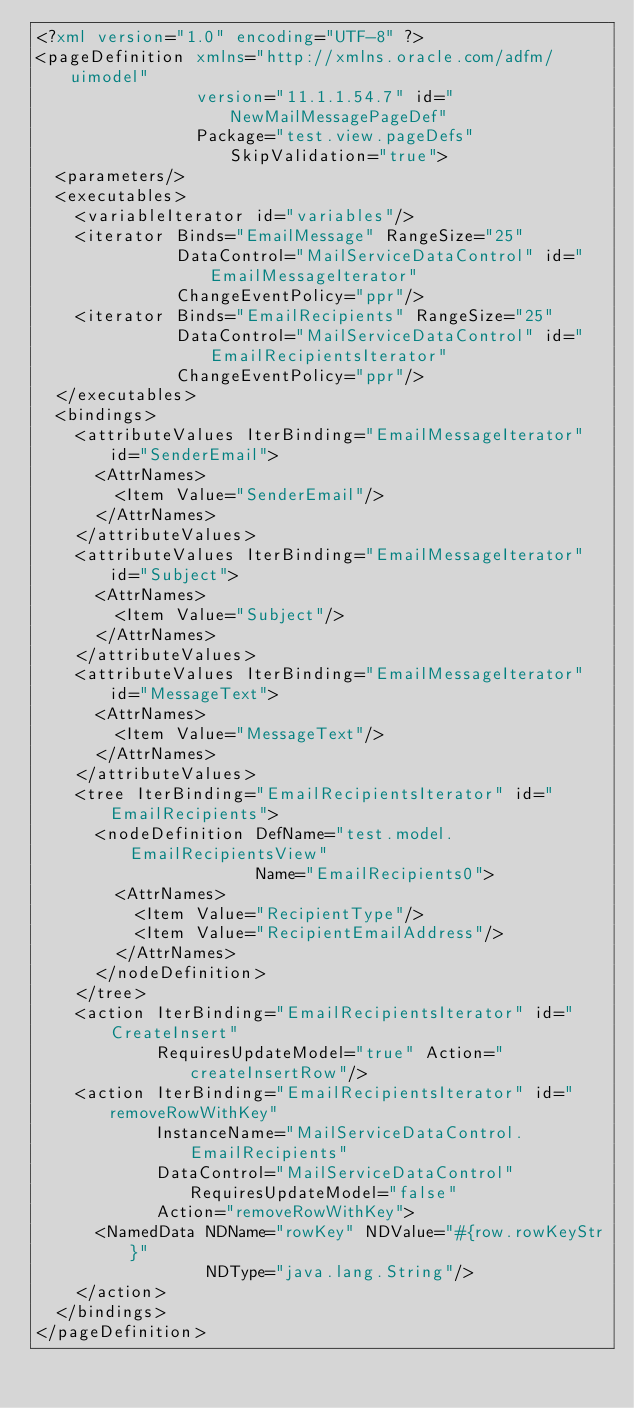<code> <loc_0><loc_0><loc_500><loc_500><_XML_><?xml version="1.0" encoding="UTF-8" ?>
<pageDefinition xmlns="http://xmlns.oracle.com/adfm/uimodel"
                version="11.1.1.54.7" id="NewMailMessagePageDef"
                Package="test.view.pageDefs" SkipValidation="true">
  <parameters/>
  <executables>
    <variableIterator id="variables"/>
    <iterator Binds="EmailMessage" RangeSize="25"
              DataControl="MailServiceDataControl" id="EmailMessageIterator"
              ChangeEventPolicy="ppr"/>
    <iterator Binds="EmailRecipients" RangeSize="25"
              DataControl="MailServiceDataControl" id="EmailRecipientsIterator"
              ChangeEventPolicy="ppr"/>
  </executables>
  <bindings>
    <attributeValues IterBinding="EmailMessageIterator" id="SenderEmail">
      <AttrNames>
        <Item Value="SenderEmail"/>
      </AttrNames>
    </attributeValues>
    <attributeValues IterBinding="EmailMessageIterator" id="Subject">
      <AttrNames>
        <Item Value="Subject"/>
      </AttrNames>
    </attributeValues>
    <attributeValues IterBinding="EmailMessageIterator" id="MessageText">
      <AttrNames>
        <Item Value="MessageText"/>
      </AttrNames>
    </attributeValues>
    <tree IterBinding="EmailRecipientsIterator" id="EmailRecipients">
      <nodeDefinition DefName="test.model.EmailRecipientsView"
                      Name="EmailRecipients0">
        <AttrNames>
          <Item Value="RecipientType"/>
          <Item Value="RecipientEmailAddress"/>
        </AttrNames>
      </nodeDefinition>
    </tree>
    <action IterBinding="EmailRecipientsIterator" id="CreateInsert"
            RequiresUpdateModel="true" Action="createInsertRow"/>
    <action IterBinding="EmailRecipientsIterator" id="removeRowWithKey"
            InstanceName="MailServiceDataControl.EmailRecipients"
            DataControl="MailServiceDataControl" RequiresUpdateModel="false"
            Action="removeRowWithKey">
      <NamedData NDName="rowKey" NDValue="#{row.rowKeyStr}"
                 NDType="java.lang.String"/>
    </action>
  </bindings>
</pageDefinition>
</code> 